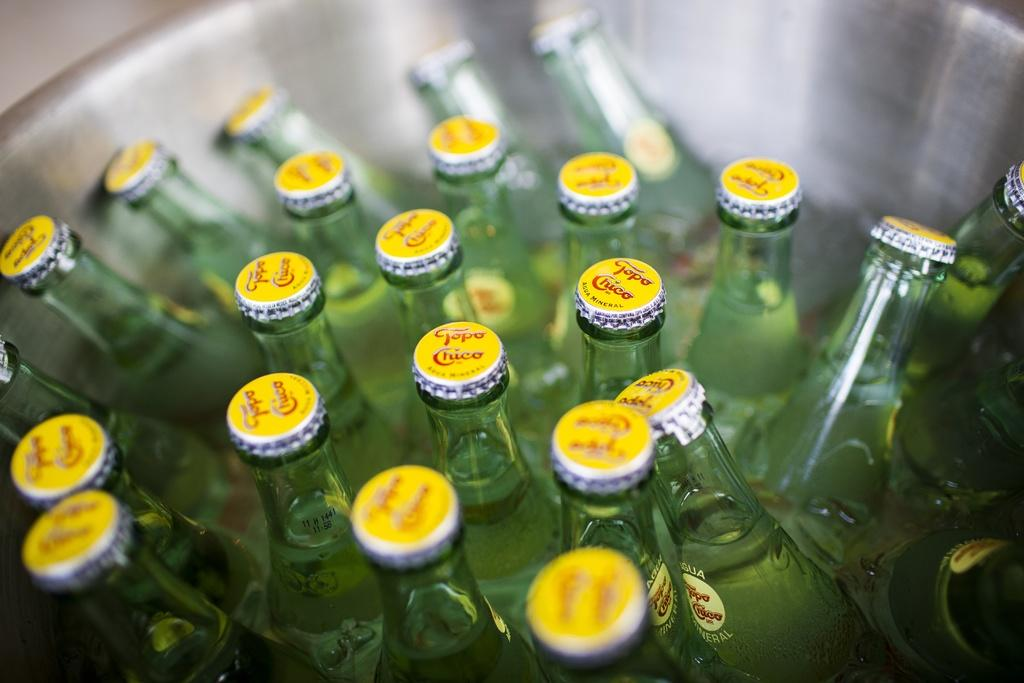What is the main subject of the image? The main subject of the image is a bunch of bottles. Can you describe the bottles in the image? Unfortunately, the facts provided do not give any details about the bottles, such as their size, color, or contents. Are there any other objects or elements in the image besides the bottles? The facts provided do not mention any other objects or elements in the image. What type of plot can be seen in the background of the image? There is no plot visible in the image, as it only features a bunch of bottles. Can you describe the mountain range in the distance of the image? There is no mountain range present in the image, as it only features a bunch of bottles. 